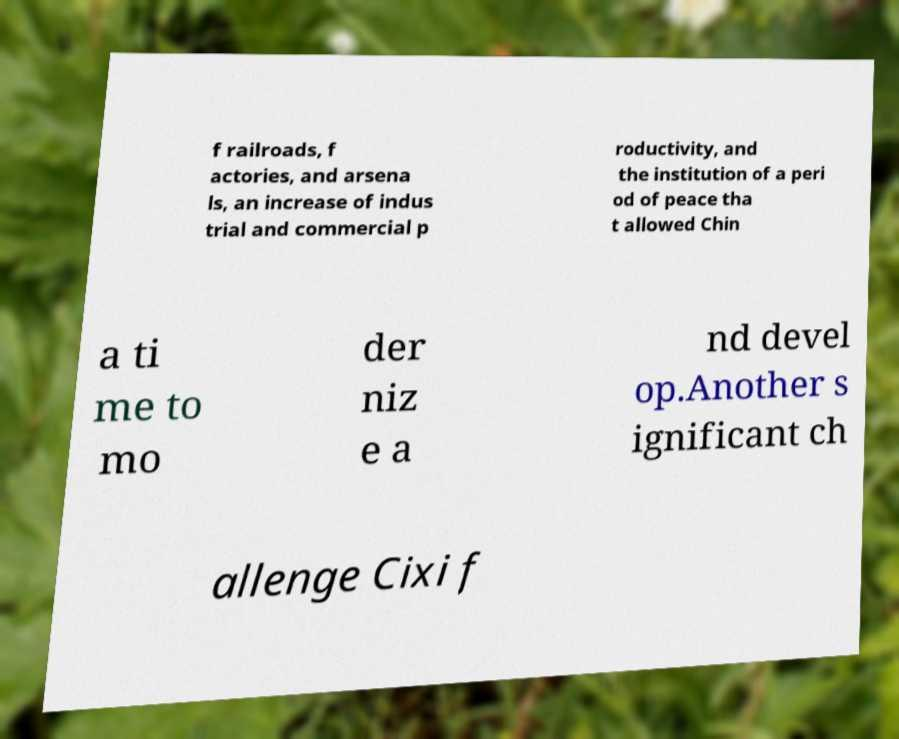I need the written content from this picture converted into text. Can you do that? f railroads, f actories, and arsena ls, an increase of indus trial and commercial p roductivity, and the institution of a peri od of peace tha t allowed Chin a ti me to mo der niz e a nd devel op.Another s ignificant ch allenge Cixi f 